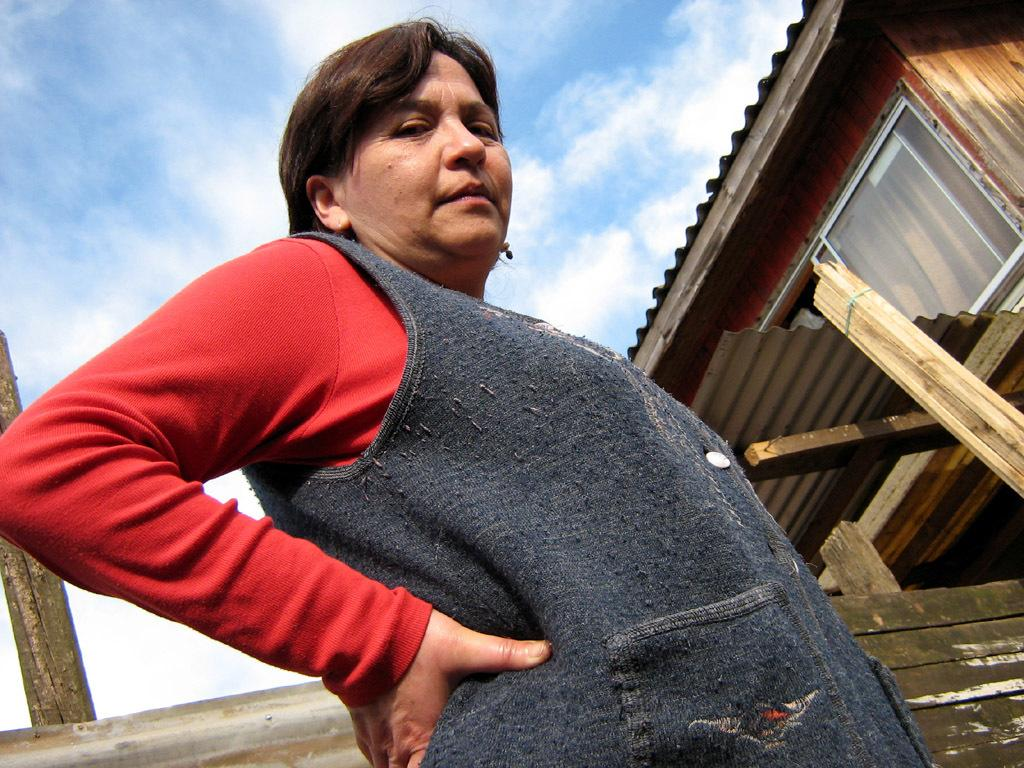What is the main subject of the image? There is a woman standing in the image. What can be seen in the background of the image? There is a house in the background of the image. Can you describe the house in the image? The house has a roof and a window. What else is visible in the image? There are wooden poles visible in the image. What is the condition of the sky in the image? The sky appears to be cloudy in the image. What type of plate is being used to hold the sponge in the image? There is no plate or sponge present in the image. How is the parcel being delivered in the image? There is no parcel being delivered in the image. 